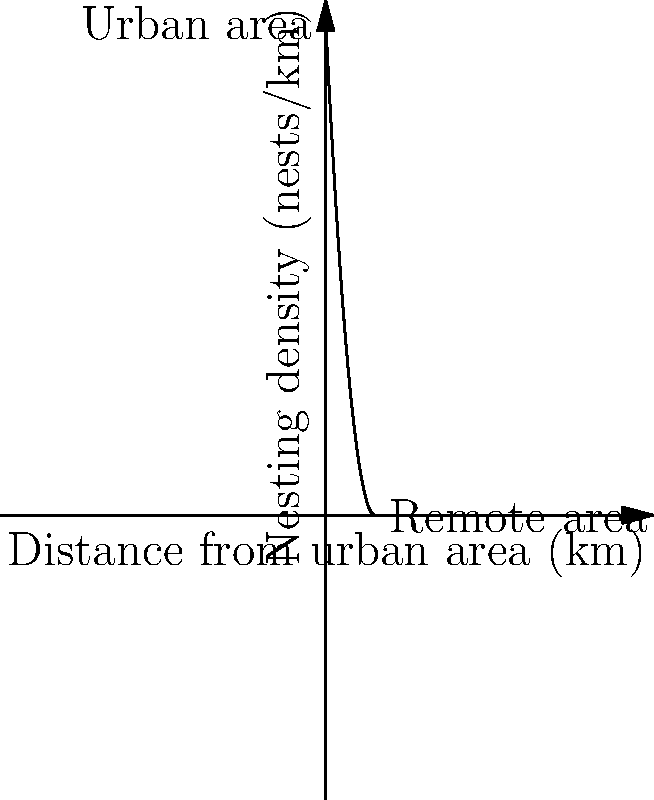A study on sea turtle nesting density along a coastline shows a relationship between distance from an urban area and nesting density. The graph represents this relationship, where the x-axis shows the distance from the urban area in kilometers, and the y-axis shows the nesting density in nests per kilometer. The function modeling this relationship is given by $f(x) = 100 - 20x + x^2$, where $x$ is the distance from the urban area in kilometers.

Calculate the rate of change in nesting density between 2 km and 5 km from the urban area. Express your answer in nests per km^2. To calculate the rate of change in nesting density between 2 km and 5 km, we need to follow these steps:

1. Calculate the nesting density at 2 km:
   $f(2) = 100 - 20(2) + 2^2 = 100 - 40 + 4 = 64$ nests/km

2. Calculate the nesting density at 5 km:
   $f(5) = 100 - 20(5) + 5^2 = 100 - 100 + 25 = 25$ nests/km

3. Calculate the change in nesting density:
   Change = $f(5) - f(2) = 25 - 64 = -39$ nests/km

4. Calculate the change in distance:
   Distance change = $5 - 2 = 3$ km

5. Calculate the rate of change (slope):
   Rate of change = $\frac{\text{Change in nesting density}}{\text{Change in distance}} = \frac{-39}{3} = -13$ nests/km^2

The negative value indicates that the nesting density decreases as we move away from the urban area in this interval.
Answer: -13 nests/km^2 